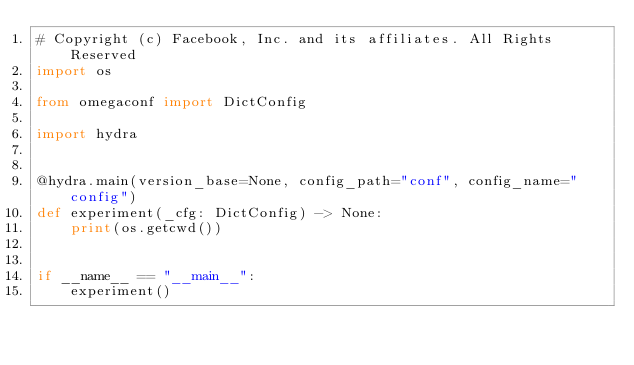<code> <loc_0><loc_0><loc_500><loc_500><_Python_># Copyright (c) Facebook, Inc. and its affiliates. All Rights Reserved
import os

from omegaconf import DictConfig

import hydra


@hydra.main(version_base=None, config_path="conf", config_name="config")
def experiment(_cfg: DictConfig) -> None:
    print(os.getcwd())


if __name__ == "__main__":
    experiment()
</code> 